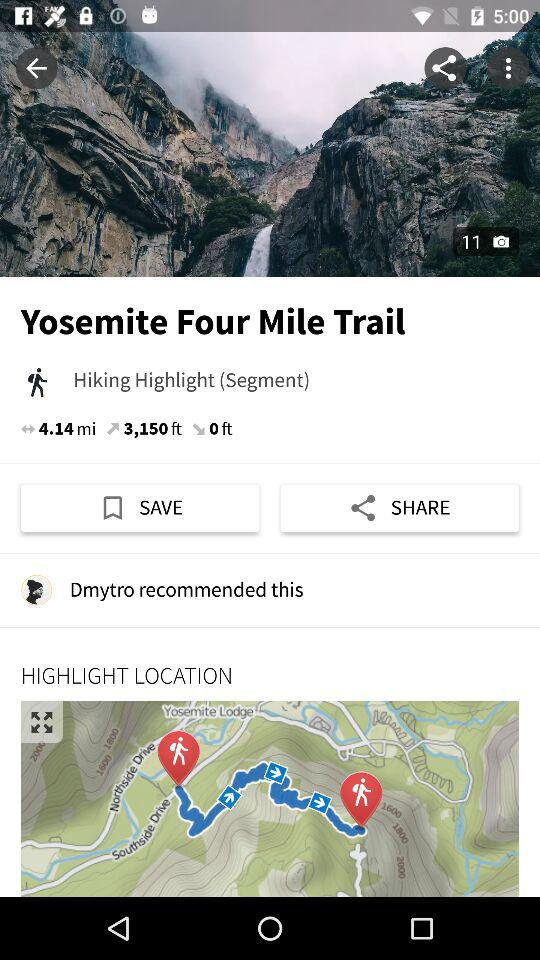What is the distance? The distance is 4.14 miles. 